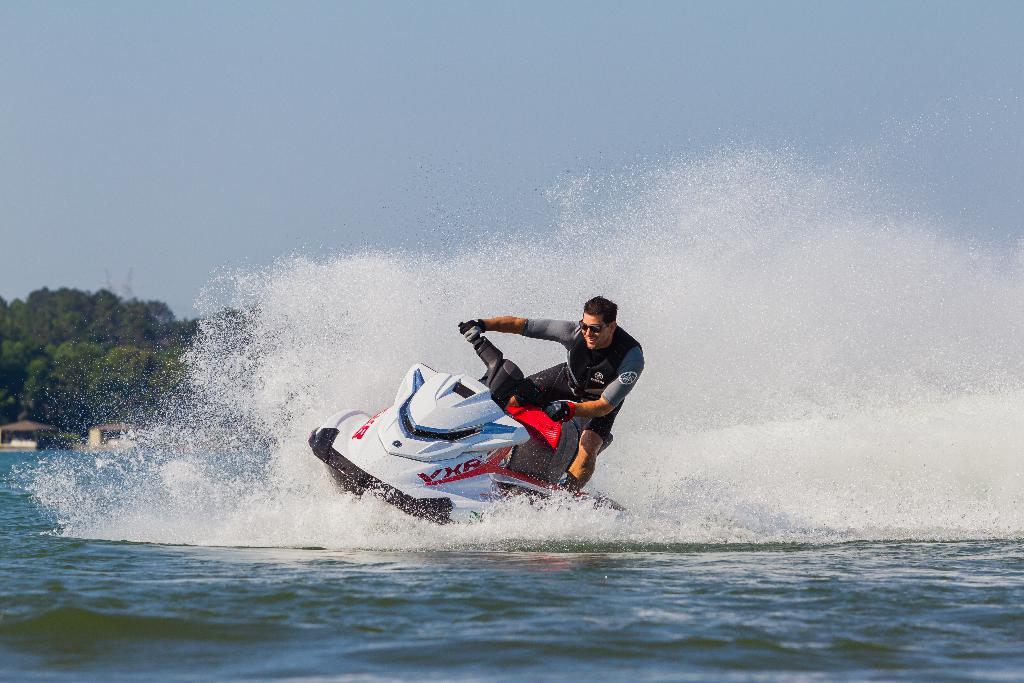Who is in the image? There is a man in the image. What is the man doing in the image? The man is on a jet ski in the image. What type of environment is visible in the image? There is water visible in the image, and there are trees and the sky in the background. How many goldfish can be seen swimming in the water in the image? There are no goldfish visible in the image; it features a man on a jet ski in water with trees and the sky in the background. 